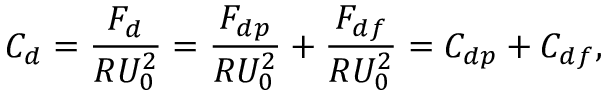<formula> <loc_0><loc_0><loc_500><loc_500>C _ { d } = \frac { F _ { d } } { R U _ { 0 } ^ { 2 } } = \frac { F _ { d p } } { R U _ { 0 } ^ { 2 } } + \frac { F _ { d f } } { R U _ { 0 } ^ { 2 } } = C _ { d p } + C _ { d f } ,</formula> 